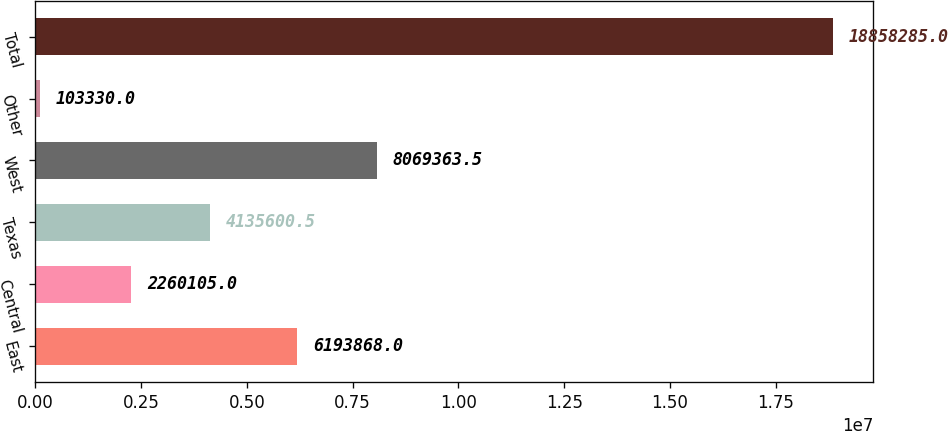Convert chart to OTSL. <chart><loc_0><loc_0><loc_500><loc_500><bar_chart><fcel>East<fcel>Central<fcel>Texas<fcel>West<fcel>Other<fcel>Total<nl><fcel>6.19387e+06<fcel>2.2601e+06<fcel>4.1356e+06<fcel>8.06936e+06<fcel>103330<fcel>1.88583e+07<nl></chart> 